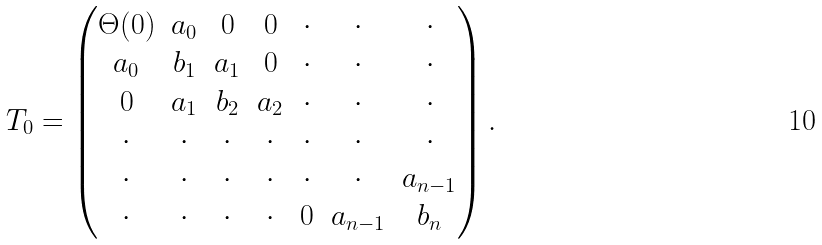<formula> <loc_0><loc_0><loc_500><loc_500>T _ { 0 } = \begin{pmatrix} \Theta ( 0 ) & a _ { 0 } & 0 & 0 & \cdot & \cdot & \cdot \\ a _ { 0 } & b _ { 1 } & a _ { 1 } & 0 & \cdot & \cdot & \cdot \\ 0 & a _ { 1 } & b _ { 2 } & a _ { 2 } & \cdot & \cdot & \cdot \\ \cdot & \cdot & \cdot & \cdot & \cdot & \cdot & \cdot \\ \cdot & \cdot & \cdot & \cdot & \cdot & \cdot & a _ { n - 1 } \\ \cdot & \cdot & \cdot & \cdot & 0 & a _ { n - 1 } & b _ { n } \end{pmatrix} .</formula> 